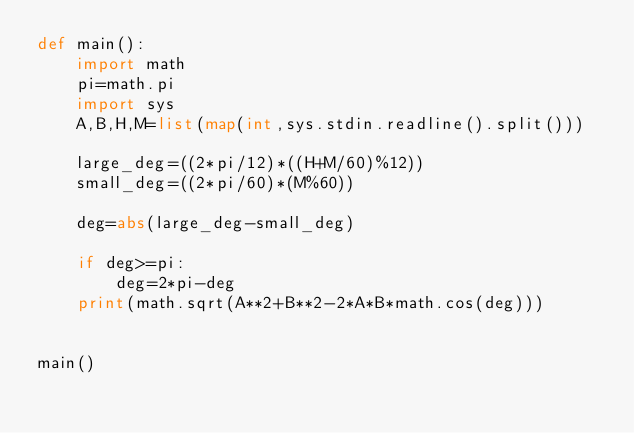Convert code to text. <code><loc_0><loc_0><loc_500><loc_500><_Python_>def main():
    import math
    pi=math.pi
    import sys
    A,B,H,M=list(map(int,sys.stdin.readline().split()))

    large_deg=((2*pi/12)*((H+M/60)%12))
    small_deg=((2*pi/60)*(M%60))

    deg=abs(large_deg-small_deg)

    if deg>=pi:
        deg=2*pi-deg
    print(math.sqrt(A**2+B**2-2*A*B*math.cos(deg)))
    

main()</code> 